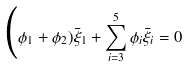<formula> <loc_0><loc_0><loc_500><loc_500>\Big ( \phi _ { 1 } + \phi _ { 2 } ) \bar { \xi } _ { 1 } + \sum _ { i = 3 } ^ { 5 } \phi _ { i } \bar { \xi } _ { i } = 0</formula> 